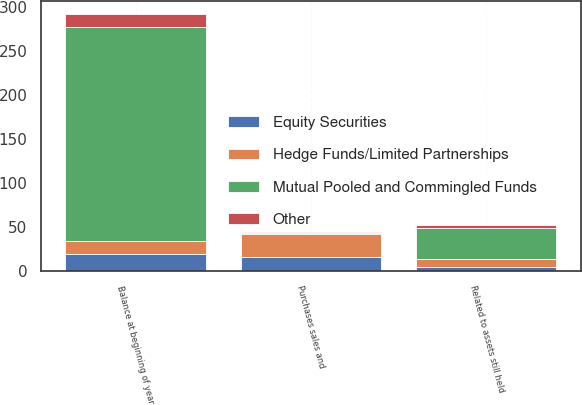<chart> <loc_0><loc_0><loc_500><loc_500><stacked_bar_chart><ecel><fcel>Balance at beginning of year<fcel>Related to assets still held<fcel>Purchases sales and<nl><fcel>Hedge Funds/Limited Partnerships<fcel>15<fcel>9<fcel>26<nl><fcel>Mutual Pooled and Commingled Funds<fcel>242<fcel>35<fcel>2<nl><fcel>Other<fcel>15<fcel>4<fcel>1<nl><fcel>Equity Securities<fcel>20<fcel>5<fcel>16<nl></chart> 